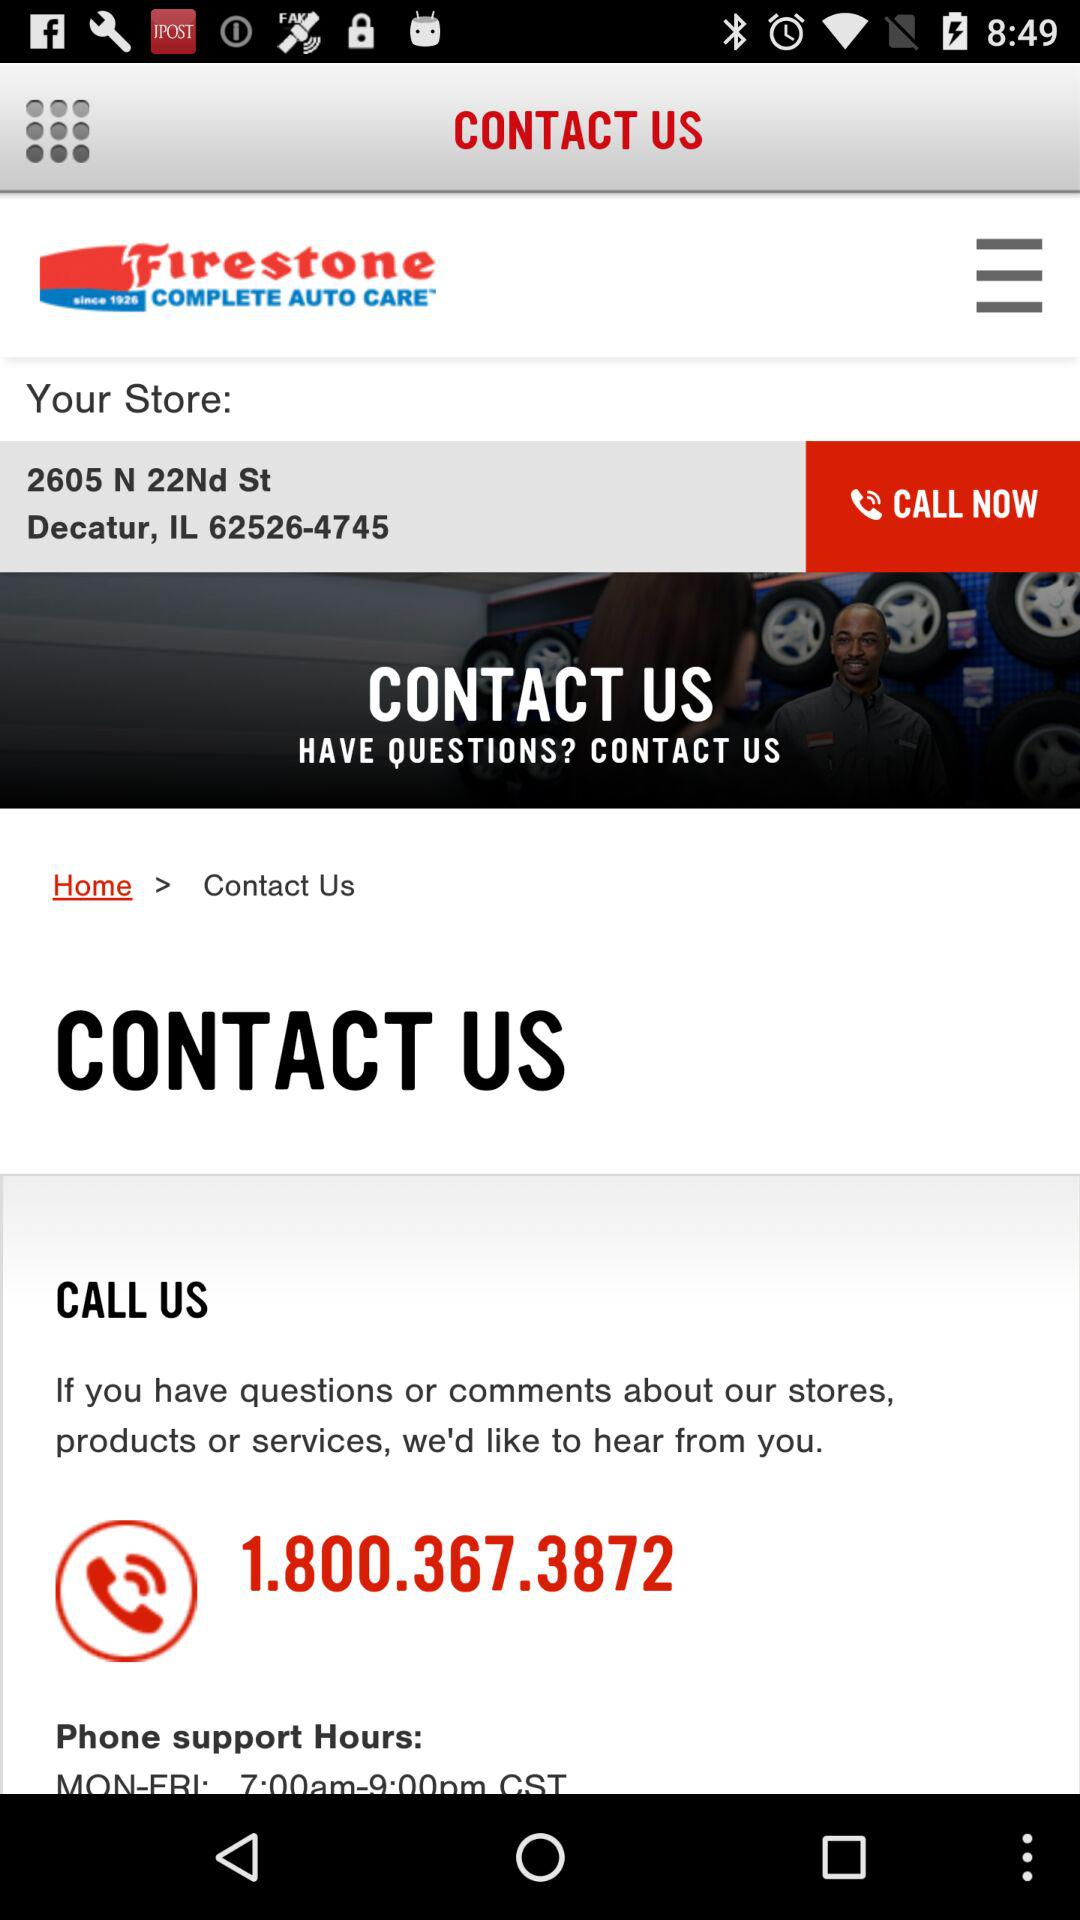What is the address of the store? The address of the store is 2605 N 22nd St, Decatur, IL 62526-4745. 